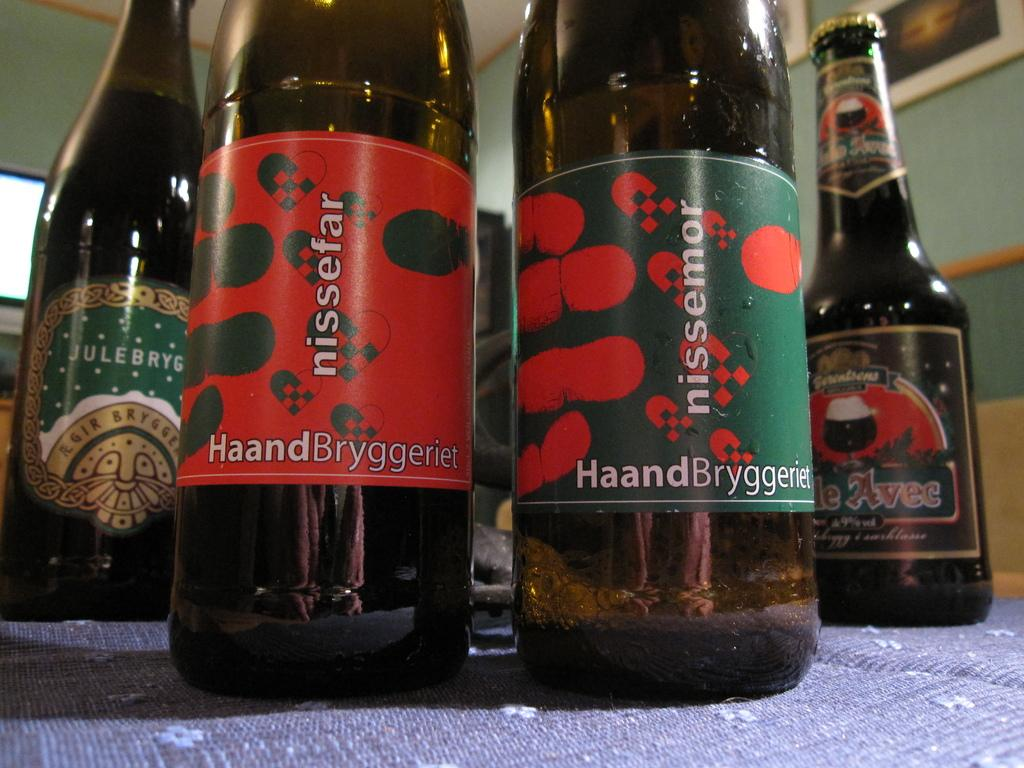<image>
Describe the image concisely. bottles of Nissefar HaandBryggeriet beer on a table 